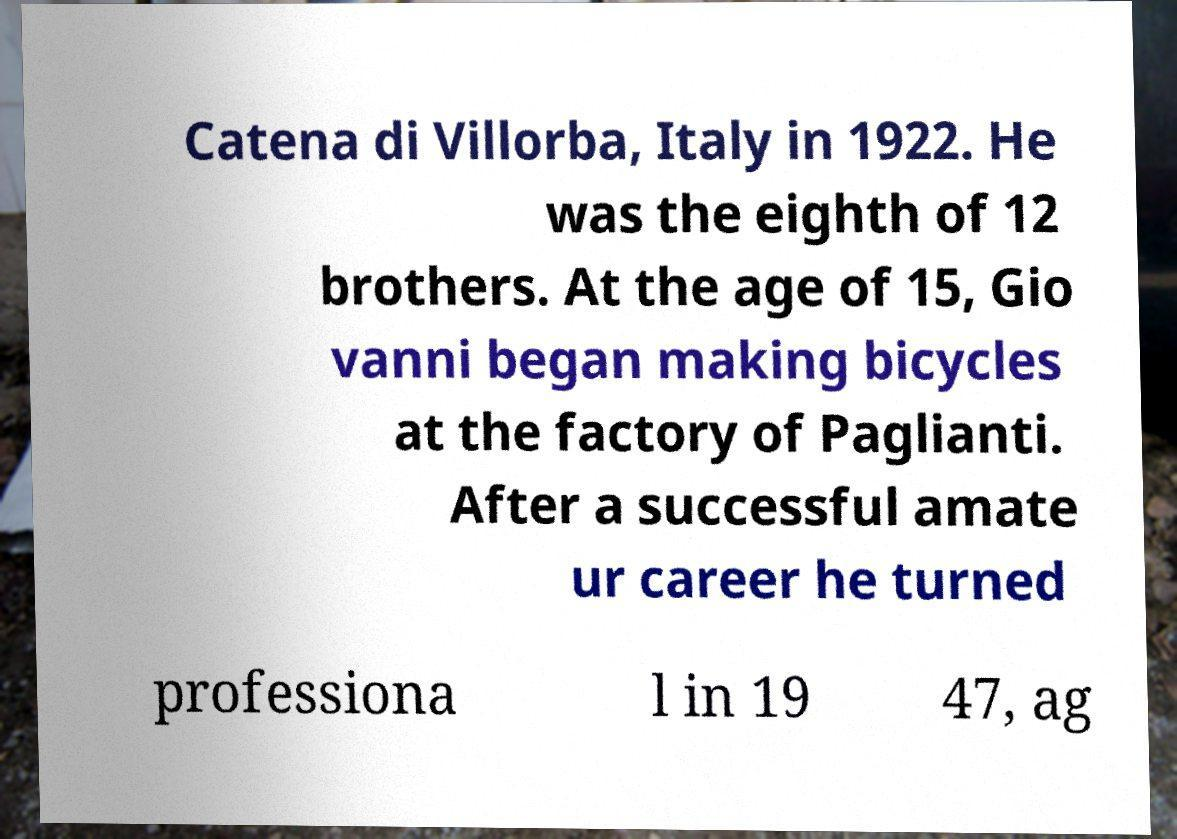I need the written content from this picture converted into text. Can you do that? Catena di Villorba, Italy in 1922. He was the eighth of 12 brothers. At the age of 15, Gio vanni began making bicycles at the factory of Paglianti. After a successful amate ur career he turned professiona l in 19 47, ag 